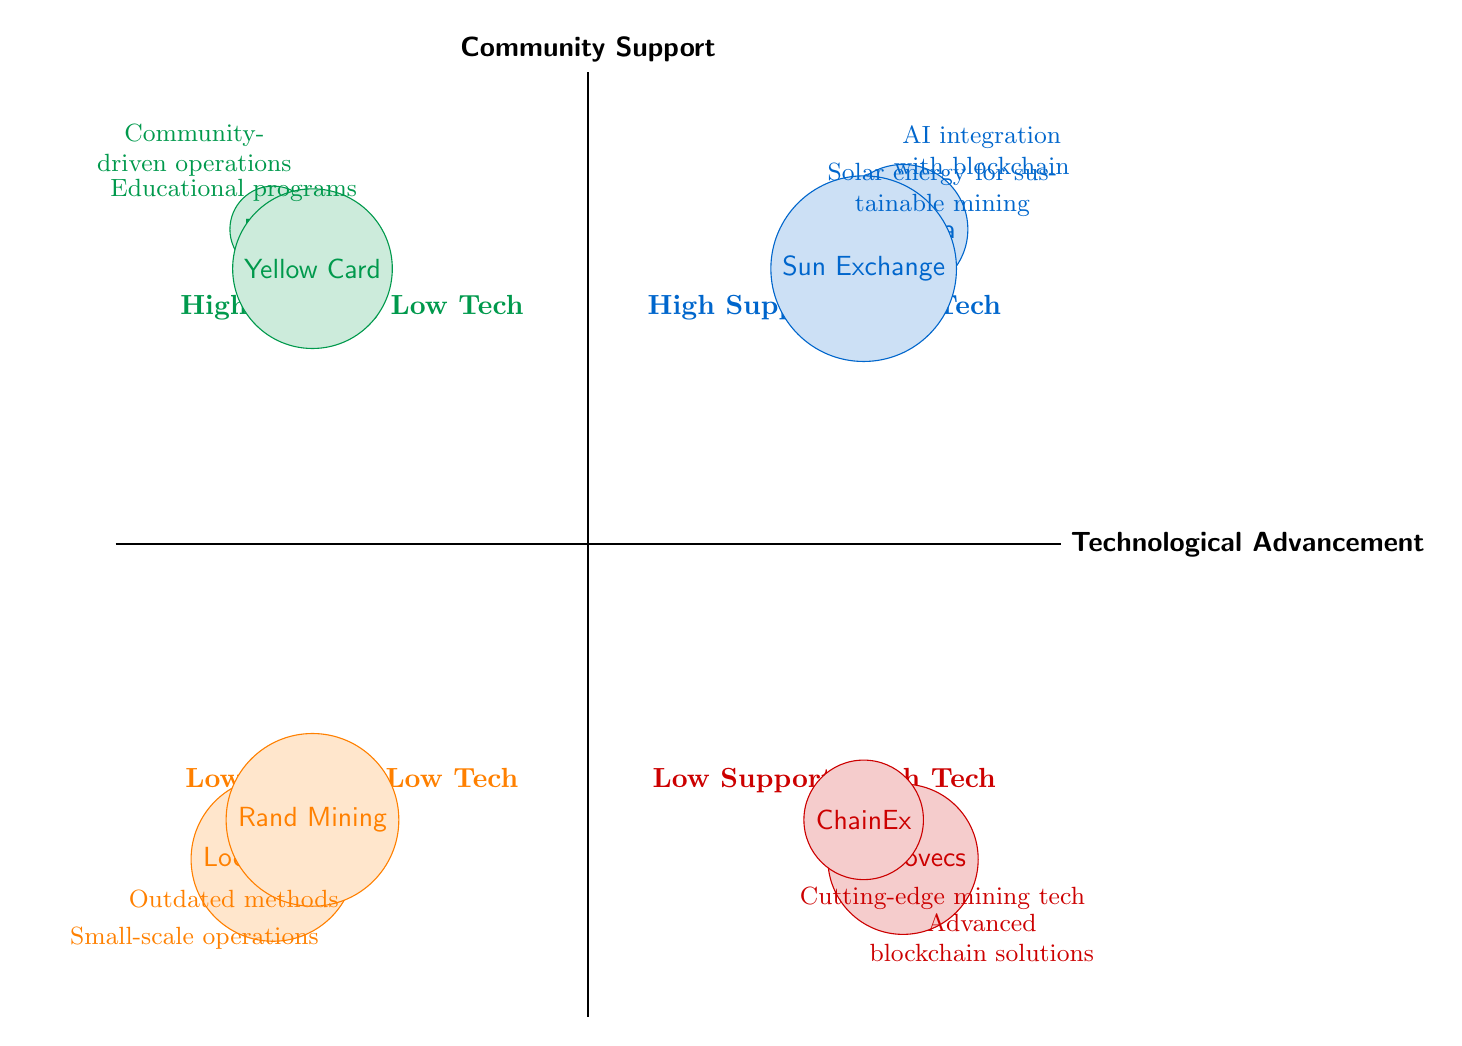What companies fall under High Community Support and High Technological Advancement? The diagram shows that the companies Bitmama and Sun Exchange are located in the quadrant representing High Community Support and High Technological Advancement. These are the only two companies in this quadrant.
Answer: Bitmama, Sun Exchange How many companies are in the Low Support, Low Tech quadrant? In the quadrant labeled Low Support, Low Tech, the diagram includes two companies: LocalCrypto and Rand Mining. Therefore, the total count for this quadrant is two companies.
Answer: 2 Which company focuses on community-driven operations? The diagram indicates that Mara, located in the High Community Support and Low Technological Advancement quadrant, focuses on community-driven operations. This is explicitly stated as part of its description.
Answer: Mara Are there any companies that combine advanced technology with significant community outreach? The diagram shows that while there are companies with advanced technology, such as Cryptovecs and ChainEx in the Low Support, High Tech quadrant, they do not have significant community outreach. Therefore, there are no companies that combine both attributes.
Answer: No What is the primary technology of Sun Exchange? The diagram describes Sun Exchange as utilizing solar energy for sustainable crypto mining, indicating that its primary technology revolves around renewable energy sources in the mining process.
Answer: Solar energy Which quadrant contains companies without any community focus? The Low Support, Low Tech quadrant contains companies that operate with limited community focus, as indicated by the characteristics labeled for LocalCrypto and Rand Mining. This answers the relationship directly by pointing to their placement in the diagram.
Answer: Low Support, Low Tech What do Cryptovecs and ChainEx have in common based on their quadrant? Both Cryptovecs and ChainEx are located in the Low Support, High Tech quadrant. This means they both have advanced technological solutions but lack significant community outreach, a common characteristic reflected in their descriptions.
Answer: Advanced technology, low community outreach What is the common characteristic of companies in the High Support, Low Tech quadrant? The characteristic common to the companies Mara and Yellow Card in the High Support, Low Tech quadrant is that they prioritize community engagement but rely on traditional technology, which is explicitly mentioned in the descriptions for both.
Answer: Community engagement with traditional technology 